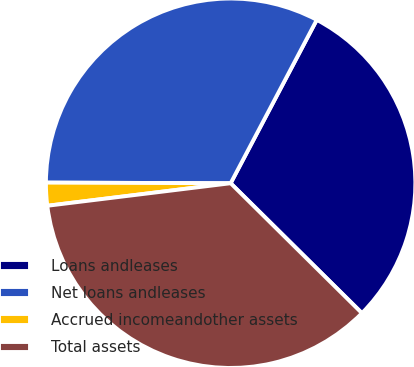<chart> <loc_0><loc_0><loc_500><loc_500><pie_chart><fcel>Loans andleases<fcel>Net loans andleases<fcel>Accrued incomeandother assets<fcel>Total assets<nl><fcel>29.7%<fcel>32.67%<fcel>2.0%<fcel>35.64%<nl></chart> 